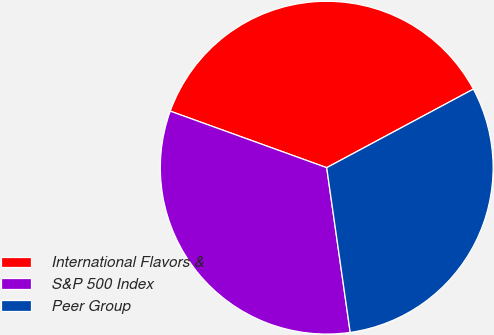<chart> <loc_0><loc_0><loc_500><loc_500><pie_chart><fcel>International Flavors &<fcel>S&P 500 Index<fcel>Peer Group<nl><fcel>36.65%<fcel>32.77%<fcel>30.57%<nl></chart> 